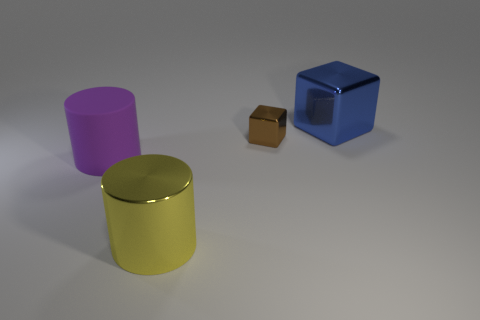Add 2 big spheres. How many objects exist? 6 Add 4 purple rubber cylinders. How many purple rubber cylinders are left? 5 Add 3 purple matte things. How many purple matte things exist? 4 Subtract 0 green blocks. How many objects are left? 4 Subtract all metal cylinders. Subtract all rubber things. How many objects are left? 2 